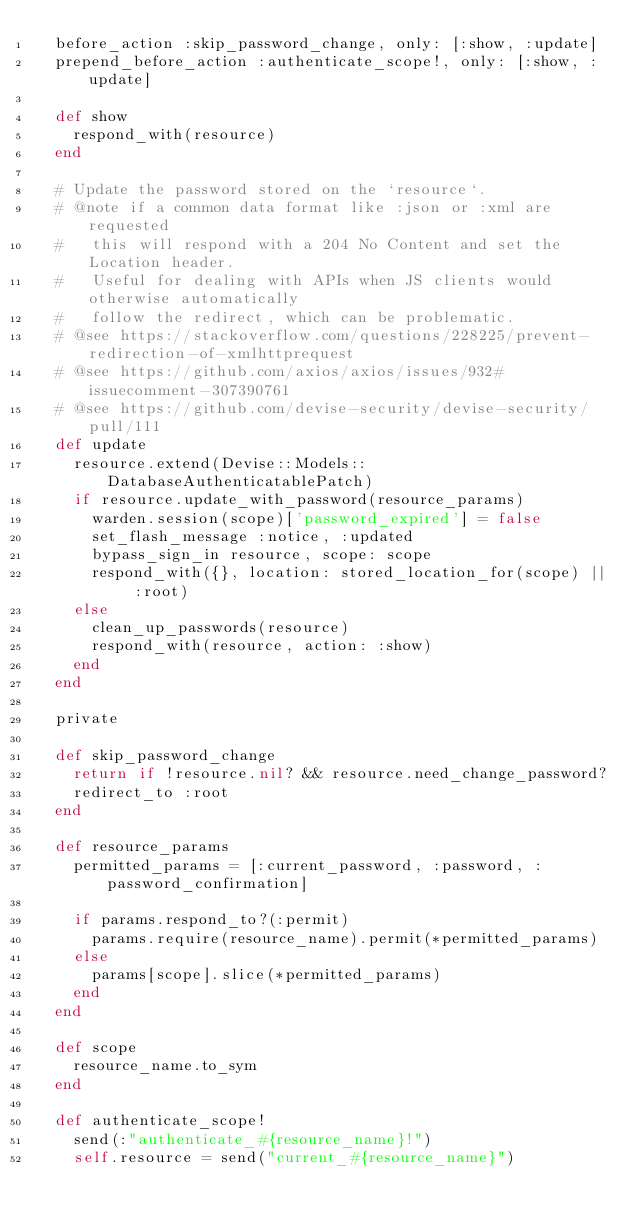<code> <loc_0><loc_0><loc_500><loc_500><_Ruby_>  before_action :skip_password_change, only: [:show, :update]
  prepend_before_action :authenticate_scope!, only: [:show, :update]

  def show
    respond_with(resource)
  end

  # Update the password stored on the `resource`.
  # @note if a common data format like :json or :xml are requested
  #   this will respond with a 204 No Content and set the Location header.
  #   Useful for dealing with APIs when JS clients would otherwise automatically
  #   follow the redirect, which can be problematic.
  # @see https://stackoverflow.com/questions/228225/prevent-redirection-of-xmlhttprequest
  # @see https://github.com/axios/axios/issues/932#issuecomment-307390761
  # @see https://github.com/devise-security/devise-security/pull/111
  def update
    resource.extend(Devise::Models::DatabaseAuthenticatablePatch)
    if resource.update_with_password(resource_params)
      warden.session(scope)['password_expired'] = false
      set_flash_message :notice, :updated
      bypass_sign_in resource, scope: scope
      respond_with({}, location: stored_location_for(scope) || :root)
    else
      clean_up_passwords(resource)
      respond_with(resource, action: :show)
    end
  end

  private

  def skip_password_change
    return if !resource.nil? && resource.need_change_password?
    redirect_to :root
  end

  def resource_params
    permitted_params = [:current_password, :password, :password_confirmation]

    if params.respond_to?(:permit)
      params.require(resource_name).permit(*permitted_params)
    else
      params[scope].slice(*permitted_params)
    end
  end

  def scope
    resource_name.to_sym
  end

  def authenticate_scope!
    send(:"authenticate_#{resource_name}!")
    self.resource = send("current_#{resource_name}")</code> 